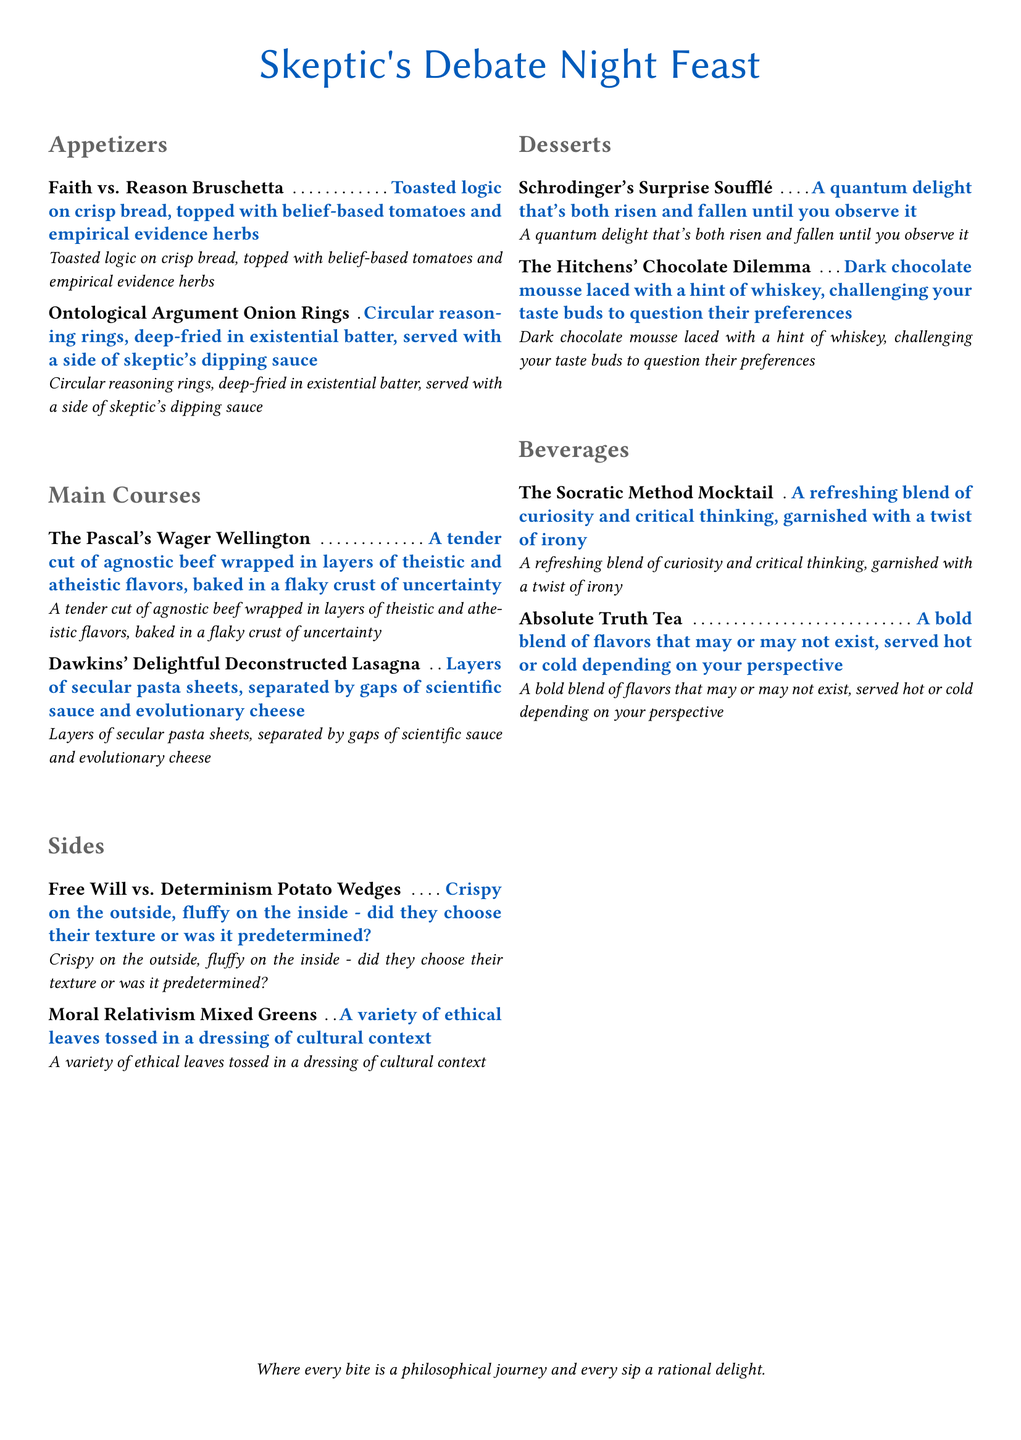What is the title of the menu? The title is prominently displayed at the top of the menu document.
Answer: Skeptic's Debate Night Feast How many appetizers are listed on the menu? The menu section for appetizers contains two items.
Answer: 2 What is the first main course listed? The main courses section starts with the first item listed at the top.
Answer: The Pascal's Wager Wellington What type of greens are included as a side dish? The side dish is specified in the title under the side section.
Answer: Mixed Greens What is the dessert named after Schrodinger related to? The dessert description suggests a relation to quantum mechanics concepts.
Answer: Quantum delight Which beverage contains a hint of whiskey? The beverage with whiskey is detailed in the title.
Answer: The Hitchens' Chocolate Dilemma What is the texture of the Free Will vs. Determinism Potato Wedges? The description of this side provides clear details about its texture.
Answer: Crispy on the outside, fluffy on the inside What philosophical debate is represented by the appetizers? The appetizers section refers directly to a key philosophical theme.
Answer: Faith vs. Reason What type of sauce is included in Dawkins' dish? The description specifies the components in the deconstructed dish related to science.
Answer: Scientific sauce 